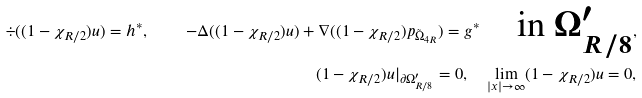Convert formula to latex. <formula><loc_0><loc_0><loc_500><loc_500>\div ( ( 1 - \chi _ { R / 2 } ) u ) = h ^ { * } , \quad - \Delta ( ( 1 - \chi _ { R / 2 } ) u ) + \nabla ( ( 1 - \chi _ { R / 2 } ) p _ { \tilde { \Omega } _ { 4 R } } ) = g ^ { * } \quad \text {in $\Omega^{\prime}_{R/8}$} , \\ ( 1 - \chi _ { R / 2 } ) u | _ { \partial \Omega ^ { \prime } _ { R / 8 } } = 0 , \quad \lim _ { | x | \rightarrow \infty } ( 1 - \chi _ { R / 2 } ) u = 0 ,</formula> 